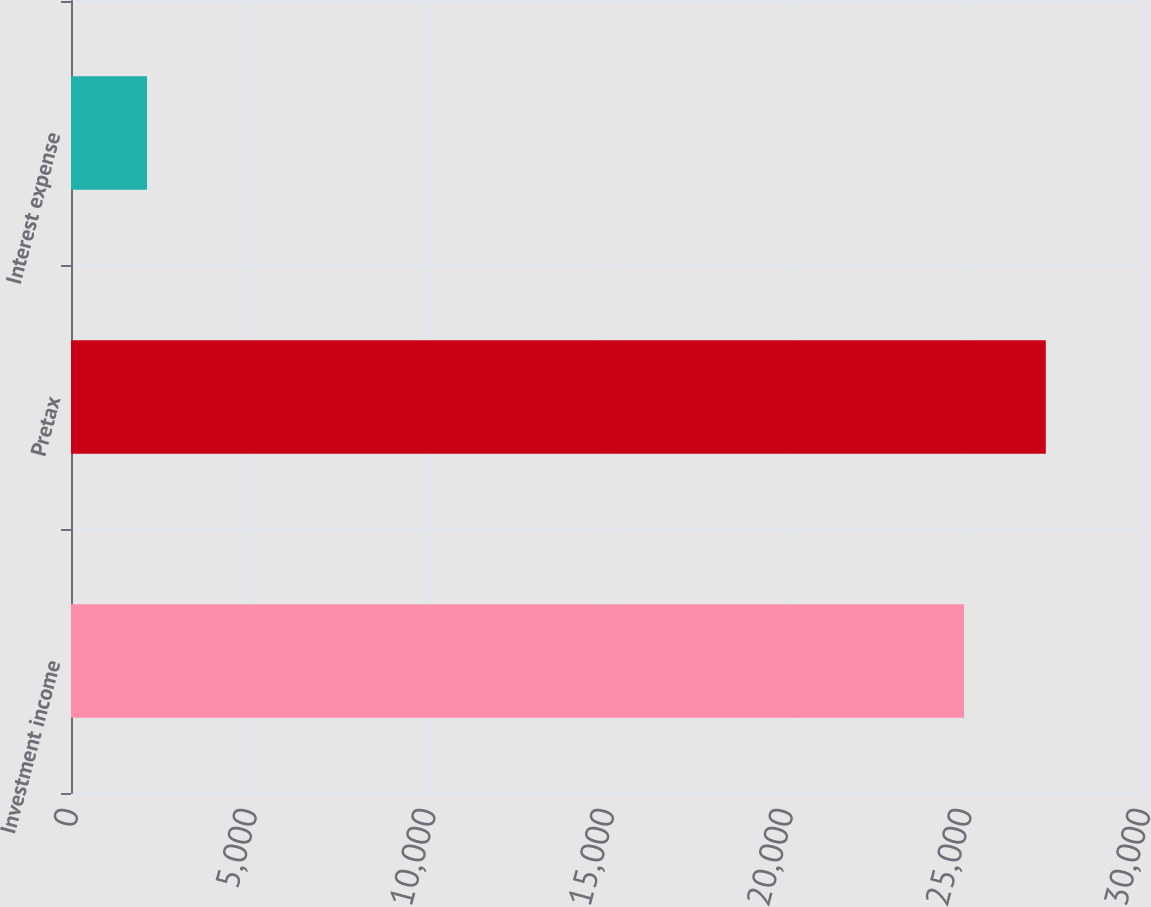<chart> <loc_0><loc_0><loc_500><loc_500><bar_chart><fcel>Investment income<fcel>Pretax<fcel>Interest expense<nl><fcel>24993<fcel>27279.5<fcel>2128<nl></chart> 